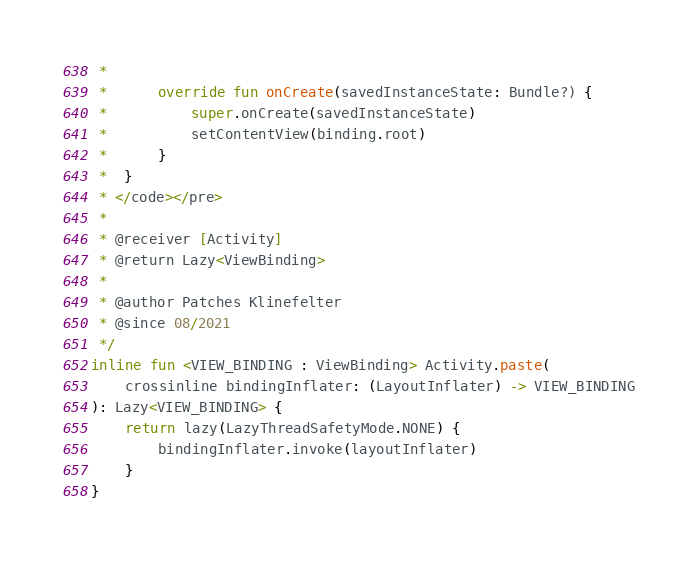<code> <loc_0><loc_0><loc_500><loc_500><_Kotlin_> *
 *      override fun onCreate(savedInstanceState: Bundle?) {
 *          super.onCreate(savedInstanceState)
 *          setContentView(binding.root)
 *      }
 *  }
 * </code></pre>
 *
 * @receiver [Activity]
 * @return Lazy<ViewBinding>
 *
 * @author Patches Klinefelter
 * @since 08/2021
 */
inline fun <VIEW_BINDING : ViewBinding> Activity.paste(
    crossinline bindingInflater: (LayoutInflater) -> VIEW_BINDING
): Lazy<VIEW_BINDING> {
    return lazy(LazyThreadSafetyMode.NONE) {
        bindingInflater.invoke(layoutInflater)
    }
}
</code> 